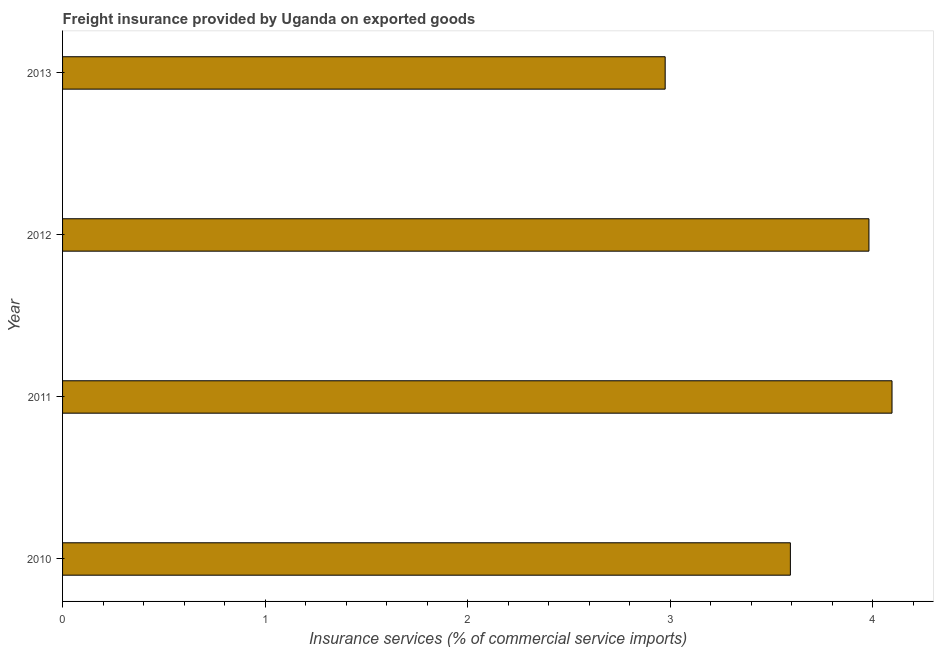Does the graph contain grids?
Ensure brevity in your answer.  No. What is the title of the graph?
Your answer should be very brief. Freight insurance provided by Uganda on exported goods . What is the label or title of the X-axis?
Your answer should be very brief. Insurance services (% of commercial service imports). What is the label or title of the Y-axis?
Provide a succinct answer. Year. What is the freight insurance in 2011?
Ensure brevity in your answer.  4.1. Across all years, what is the maximum freight insurance?
Ensure brevity in your answer.  4.1. Across all years, what is the minimum freight insurance?
Make the answer very short. 2.98. In which year was the freight insurance maximum?
Provide a short and direct response. 2011. What is the sum of the freight insurance?
Make the answer very short. 14.65. What is the difference between the freight insurance in 2010 and 2013?
Provide a succinct answer. 0.62. What is the average freight insurance per year?
Your response must be concise. 3.66. What is the median freight insurance?
Ensure brevity in your answer.  3.79. What is the ratio of the freight insurance in 2011 to that in 2013?
Offer a terse response. 1.38. Is the freight insurance in 2011 less than that in 2012?
Offer a very short reply. No. Is the difference between the freight insurance in 2010 and 2012 greater than the difference between any two years?
Your response must be concise. No. What is the difference between the highest and the second highest freight insurance?
Provide a short and direct response. 0.11. Is the sum of the freight insurance in 2010 and 2011 greater than the maximum freight insurance across all years?
Your answer should be compact. Yes. What is the difference between the highest and the lowest freight insurance?
Give a very brief answer. 1.12. In how many years, is the freight insurance greater than the average freight insurance taken over all years?
Offer a terse response. 2. Are all the bars in the graph horizontal?
Keep it short and to the point. Yes. Are the values on the major ticks of X-axis written in scientific E-notation?
Make the answer very short. No. What is the Insurance services (% of commercial service imports) in 2010?
Your answer should be very brief. 3.59. What is the Insurance services (% of commercial service imports) of 2011?
Offer a very short reply. 4.1. What is the Insurance services (% of commercial service imports) in 2012?
Your answer should be very brief. 3.98. What is the Insurance services (% of commercial service imports) in 2013?
Your answer should be very brief. 2.98. What is the difference between the Insurance services (% of commercial service imports) in 2010 and 2011?
Your response must be concise. -0.5. What is the difference between the Insurance services (% of commercial service imports) in 2010 and 2012?
Make the answer very short. -0.39. What is the difference between the Insurance services (% of commercial service imports) in 2010 and 2013?
Give a very brief answer. 0.62. What is the difference between the Insurance services (% of commercial service imports) in 2011 and 2012?
Give a very brief answer. 0.11. What is the difference between the Insurance services (% of commercial service imports) in 2011 and 2013?
Your response must be concise. 1.12. What is the difference between the Insurance services (% of commercial service imports) in 2012 and 2013?
Provide a succinct answer. 1.01. What is the ratio of the Insurance services (% of commercial service imports) in 2010 to that in 2011?
Provide a short and direct response. 0.88. What is the ratio of the Insurance services (% of commercial service imports) in 2010 to that in 2012?
Make the answer very short. 0.9. What is the ratio of the Insurance services (% of commercial service imports) in 2010 to that in 2013?
Your answer should be compact. 1.21. What is the ratio of the Insurance services (% of commercial service imports) in 2011 to that in 2013?
Keep it short and to the point. 1.38. What is the ratio of the Insurance services (% of commercial service imports) in 2012 to that in 2013?
Offer a very short reply. 1.34. 